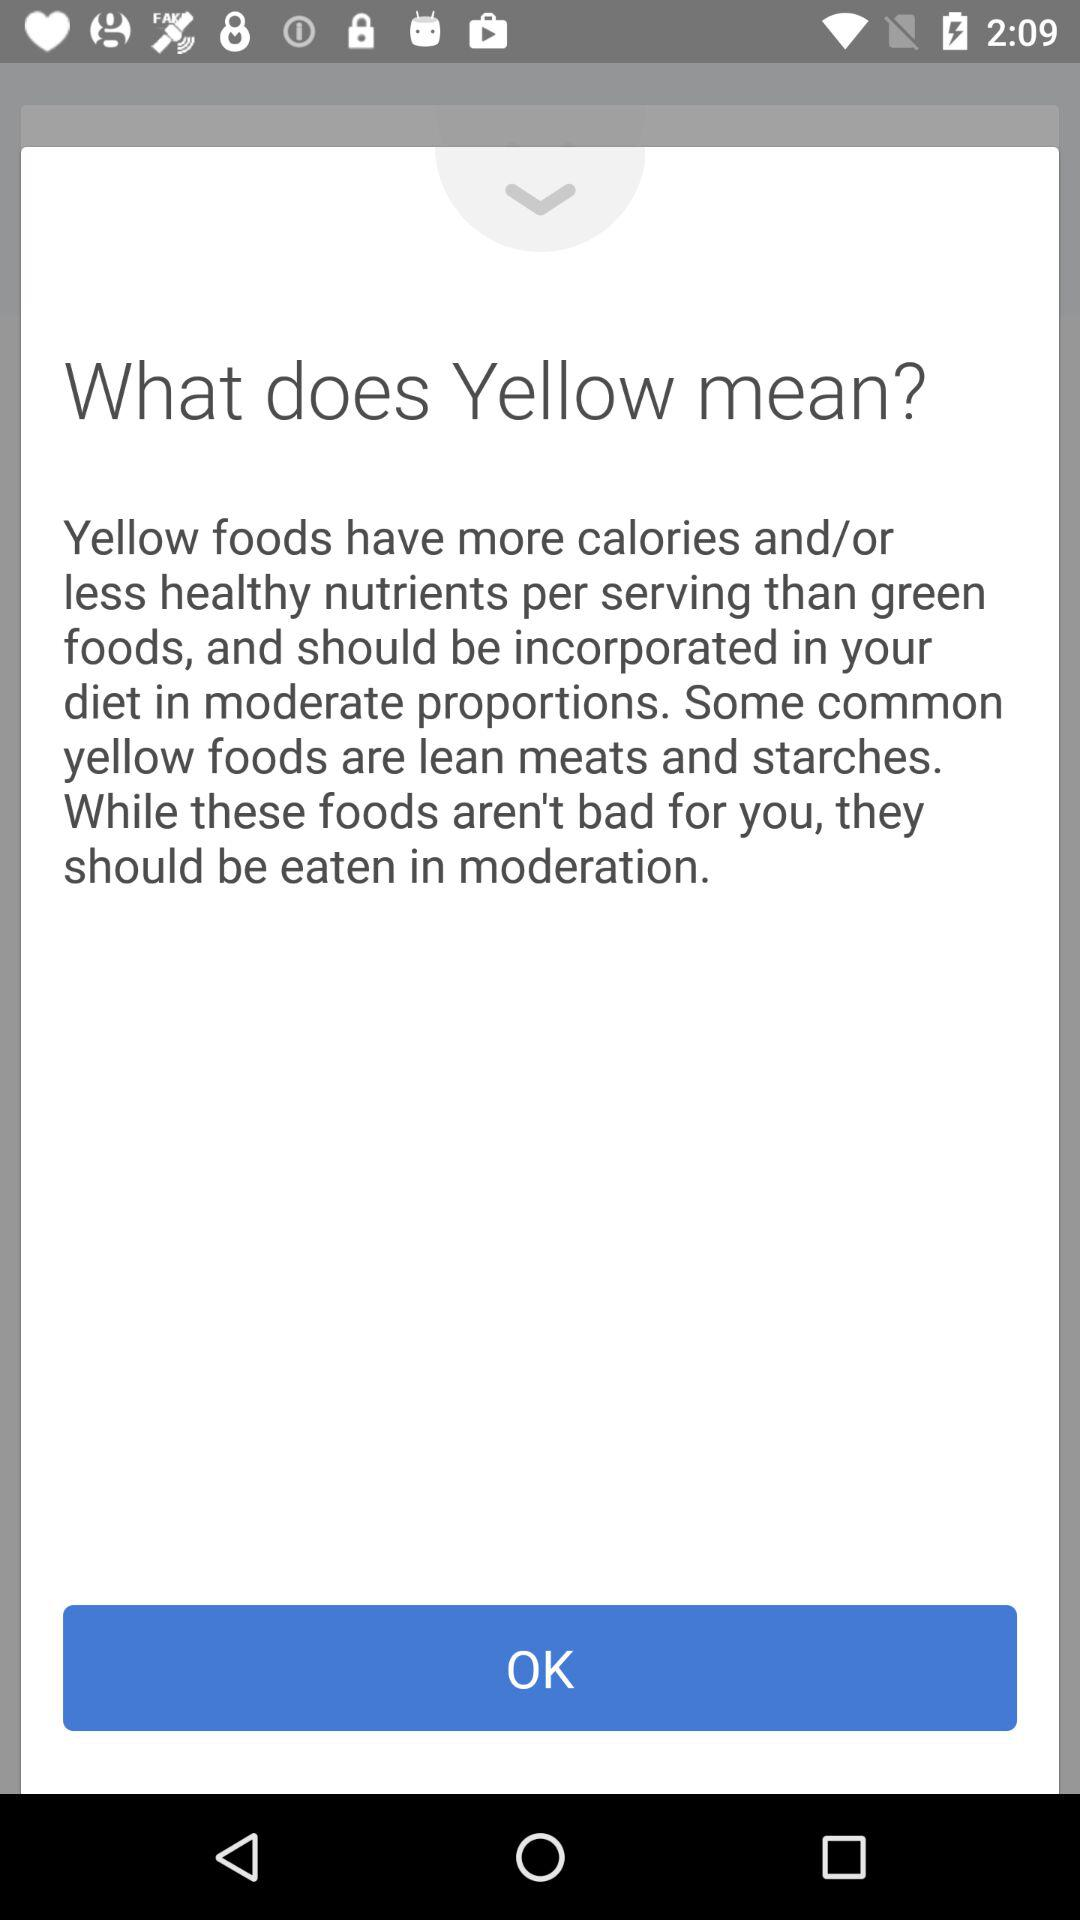Which foods have more calories and less healthy nutrients? Foods that have more calories and less healthy nutrients are yellow foods. 